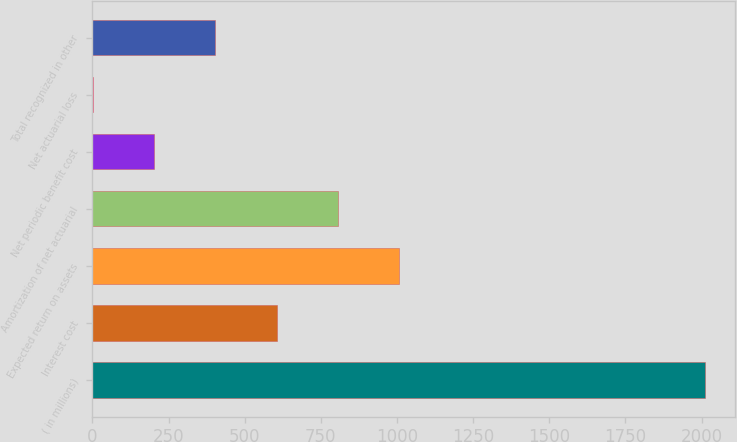Convert chart to OTSL. <chart><loc_0><loc_0><loc_500><loc_500><bar_chart><fcel>( in millions)<fcel>Interest cost<fcel>Expected return on assets<fcel>Amortization of net actuarial<fcel>Net periodic benefit cost<fcel>Net actuarial loss<fcel>Total recognized in other<nl><fcel>2010<fcel>604.4<fcel>1006<fcel>805.2<fcel>202.8<fcel>2<fcel>403.6<nl></chart> 